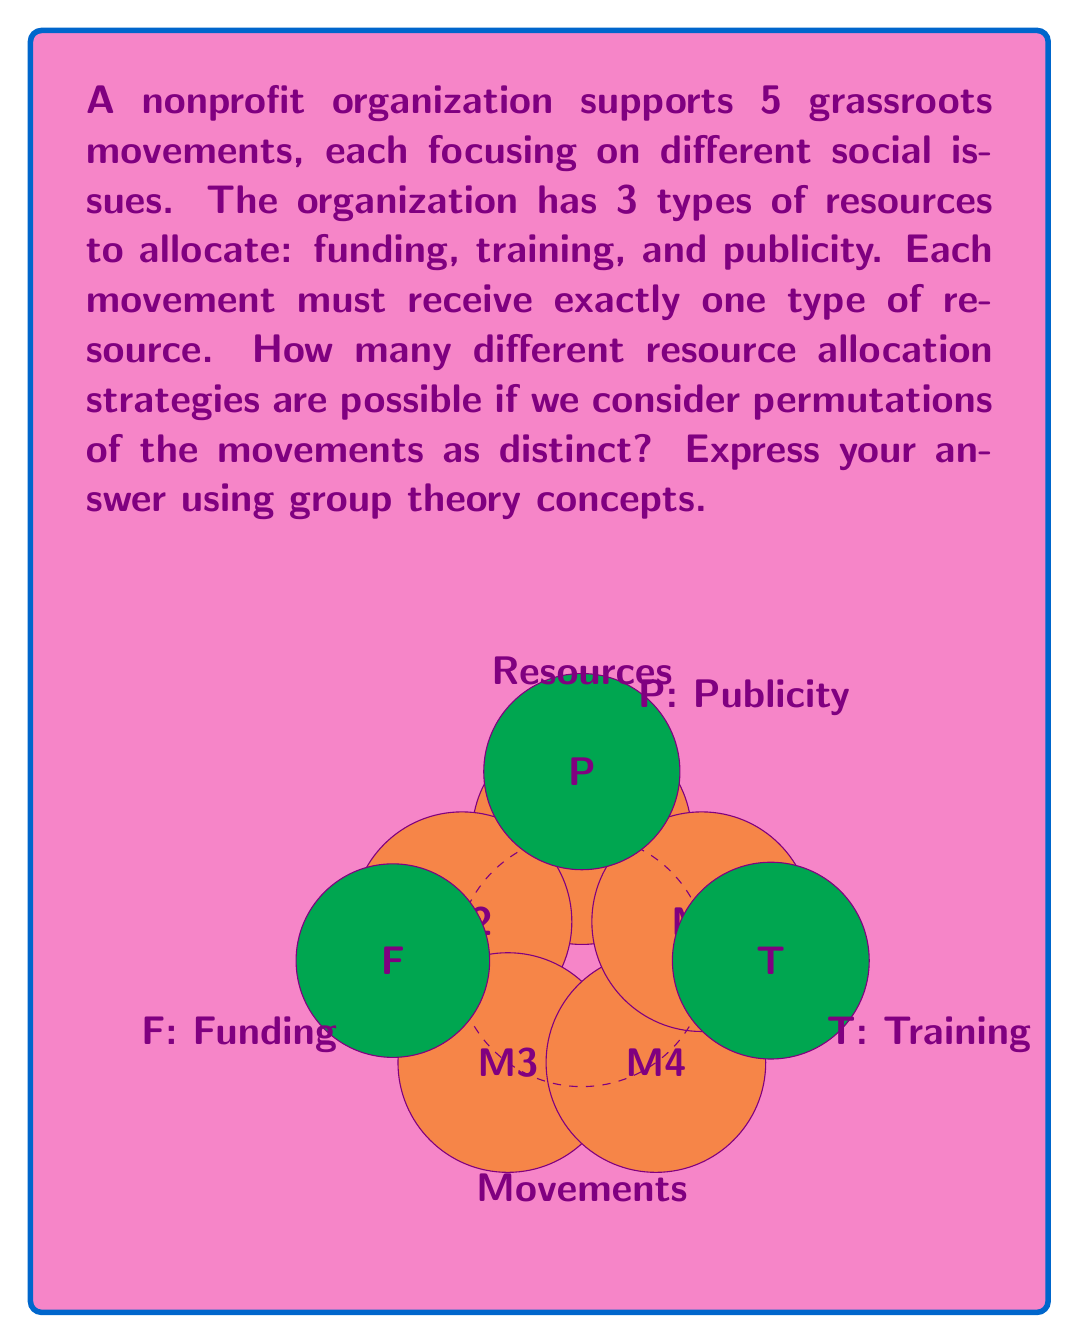Show me your answer to this math problem. Let's approach this step-by-step using group theory concepts:

1) First, we need to recognize that this problem involves the symmetric group $S_5$ (permutations of 5 elements) and the set of functions from a 5-element set to a 3-element set.

2) The number of ways to assign resources to movements is equivalent to the number of functions from a set of 5 elements (movements) to a set of 3 elements (resources). This is $3^5 = 243$.

3) However, we need to consider permutations of the movements as distinct. This means we need to consider all possible orderings of the movements for each resource allocation.

4) The number of permutations of 5 elements is $|S_5| = 5! = 120$.

5) By the multiplication principle, the total number of distinct resource allocation strategies is the product of the number of ways to assign resources and the number of permutations of movements:

   $$ 3^5 \cdot |S_5| = 243 \cdot 120 = 29,160 $$

6) In group theory terms, this can be seen as the order of the wreath product of $S_3$ (permutations of 3 resources) and $S_5$ (permutations of 5 movements):

   $$ |S_3 \wr S_5| = |S_3|^5 \cdot |S_5| = 3^5 \cdot 5! = 29,160 $$

This wreath product represents all possible ways of assigning resources to movements and then permuting the movements.
Answer: $29,160$ 